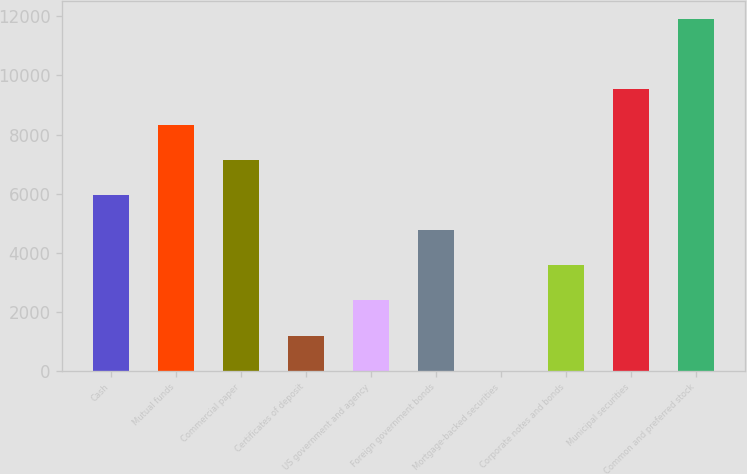<chart> <loc_0><loc_0><loc_500><loc_500><bar_chart><fcel>Cash<fcel>Mutual funds<fcel>Commercial paper<fcel>Certificates of deposit<fcel>US government and agency<fcel>Foreign government bonds<fcel>Mortgage-backed securities<fcel>Corporate notes and bonds<fcel>Municipal securities<fcel>Common and preferred stock<nl><fcel>5955.69<fcel>8337.83<fcel>7146.76<fcel>1191.41<fcel>2382.48<fcel>4764.62<fcel>0.34<fcel>3573.55<fcel>9528.9<fcel>11911<nl></chart> 